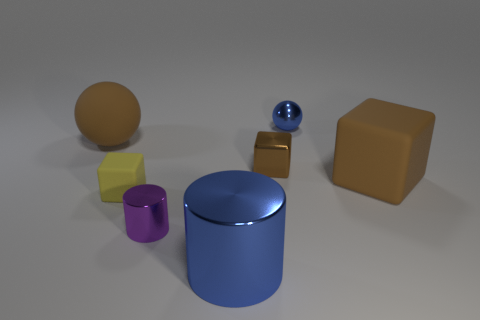Add 3 brown metallic cylinders. How many objects exist? 10 Subtract all blocks. How many objects are left? 4 Subtract 1 yellow cubes. How many objects are left? 6 Subtract all purple objects. Subtract all tiny brown cubes. How many objects are left? 5 Add 6 metallic cubes. How many metallic cubes are left? 7 Add 4 large gray metal blocks. How many large gray metal blocks exist? 4 